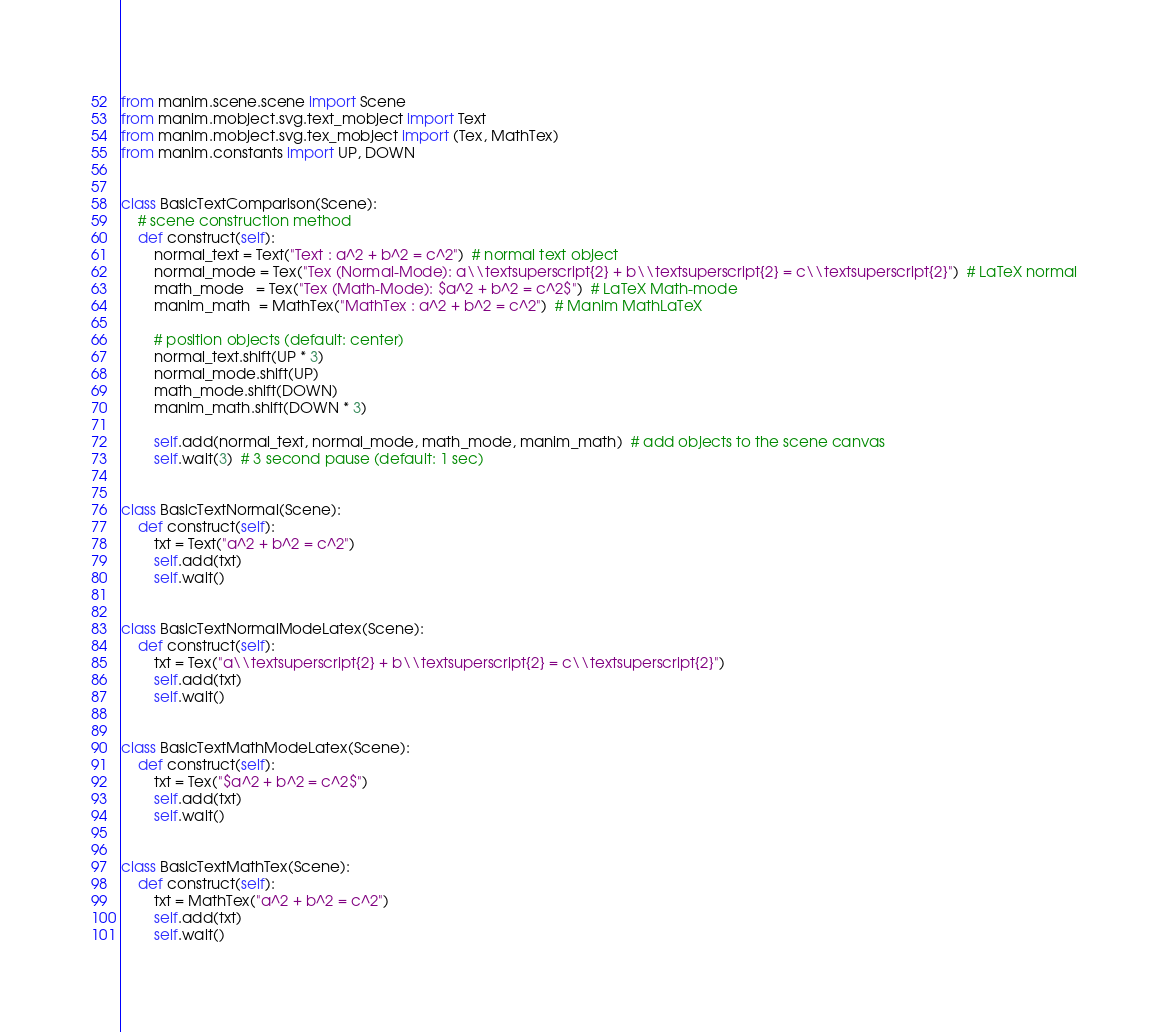Convert code to text. <code><loc_0><loc_0><loc_500><loc_500><_Python_>
from manim.scene.scene import Scene
from manim.mobject.svg.text_mobject import Text
from manim.mobject.svg.tex_mobject import (Tex, MathTex)
from manim.constants import UP, DOWN


class BasicTextComparison(Scene):
    # scene construction method
    def construct(self):
        normal_text = Text("Text : a^2 + b^2 = c^2")  # normal text object
        normal_mode = Tex("Tex (Normal-Mode): a\\textsuperscript{2} + b\\textsuperscript{2} = c\\textsuperscript{2}")  # LaTeX normal
        math_mode   = Tex("Tex (Math-Mode): $a^2 + b^2 = c^2$")  # LaTeX Math-mode
        manim_math  = MathTex("MathTex : a^2 + b^2 = c^2")  # Manim MathLaTeX

        # position objects (default: center)
        normal_text.shift(UP * 3)
        normal_mode.shift(UP)
        math_mode.shift(DOWN)
        manim_math.shift(DOWN * 3)

        self.add(normal_text, normal_mode, math_mode, manim_math)  # add objects to the scene canvas
        self.wait(3)  # 3 second pause (default: 1 sec)


class BasicTextNormal(Scene):
    def construct(self):
        txt = Text("a^2 + b^2 = c^2")
        self.add(txt)
        self.wait()


class BasicTextNormalModeLatex(Scene):
    def construct(self):
        txt = Tex("a\\textsuperscript{2} + b\\textsuperscript{2} = c\\textsuperscript{2}")
        self.add(txt)
        self.wait()


class BasicTextMathModeLatex(Scene):
    def construct(self):
        txt = Tex("$a^2 + b^2 = c^2$")
        self.add(txt)
        self.wait()


class BasicTextMathTex(Scene):
    def construct(self):
        txt = MathTex("a^2 + b^2 = c^2")
        self.add(txt)
        self.wait()
</code> 